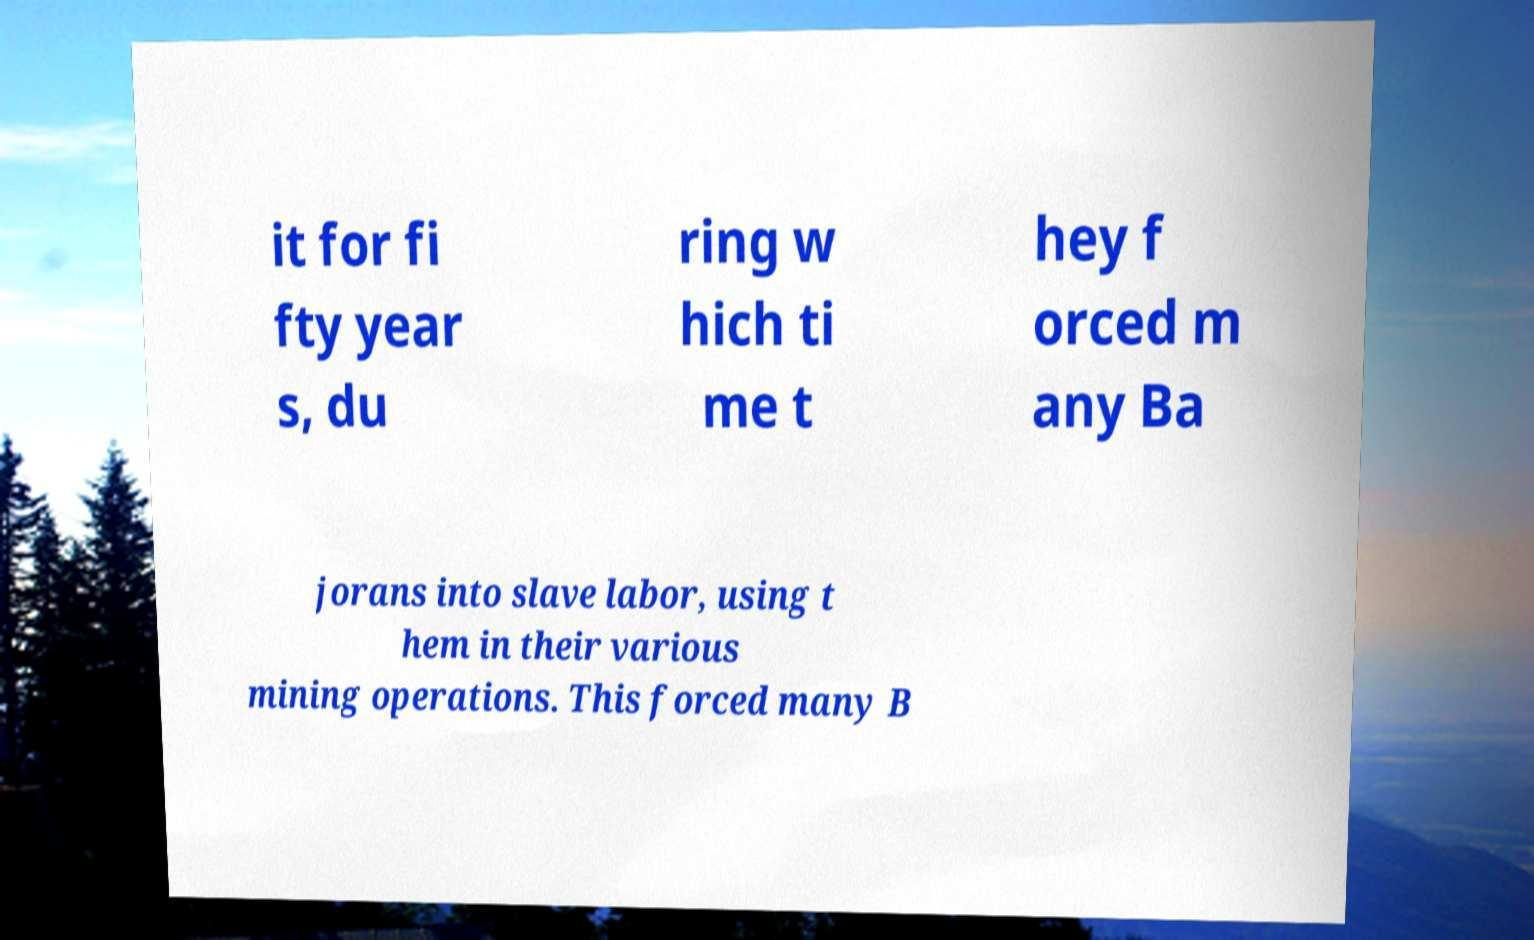Please read and relay the text visible in this image. What does it say? it for fi fty year s, du ring w hich ti me t hey f orced m any Ba jorans into slave labor, using t hem in their various mining operations. This forced many B 